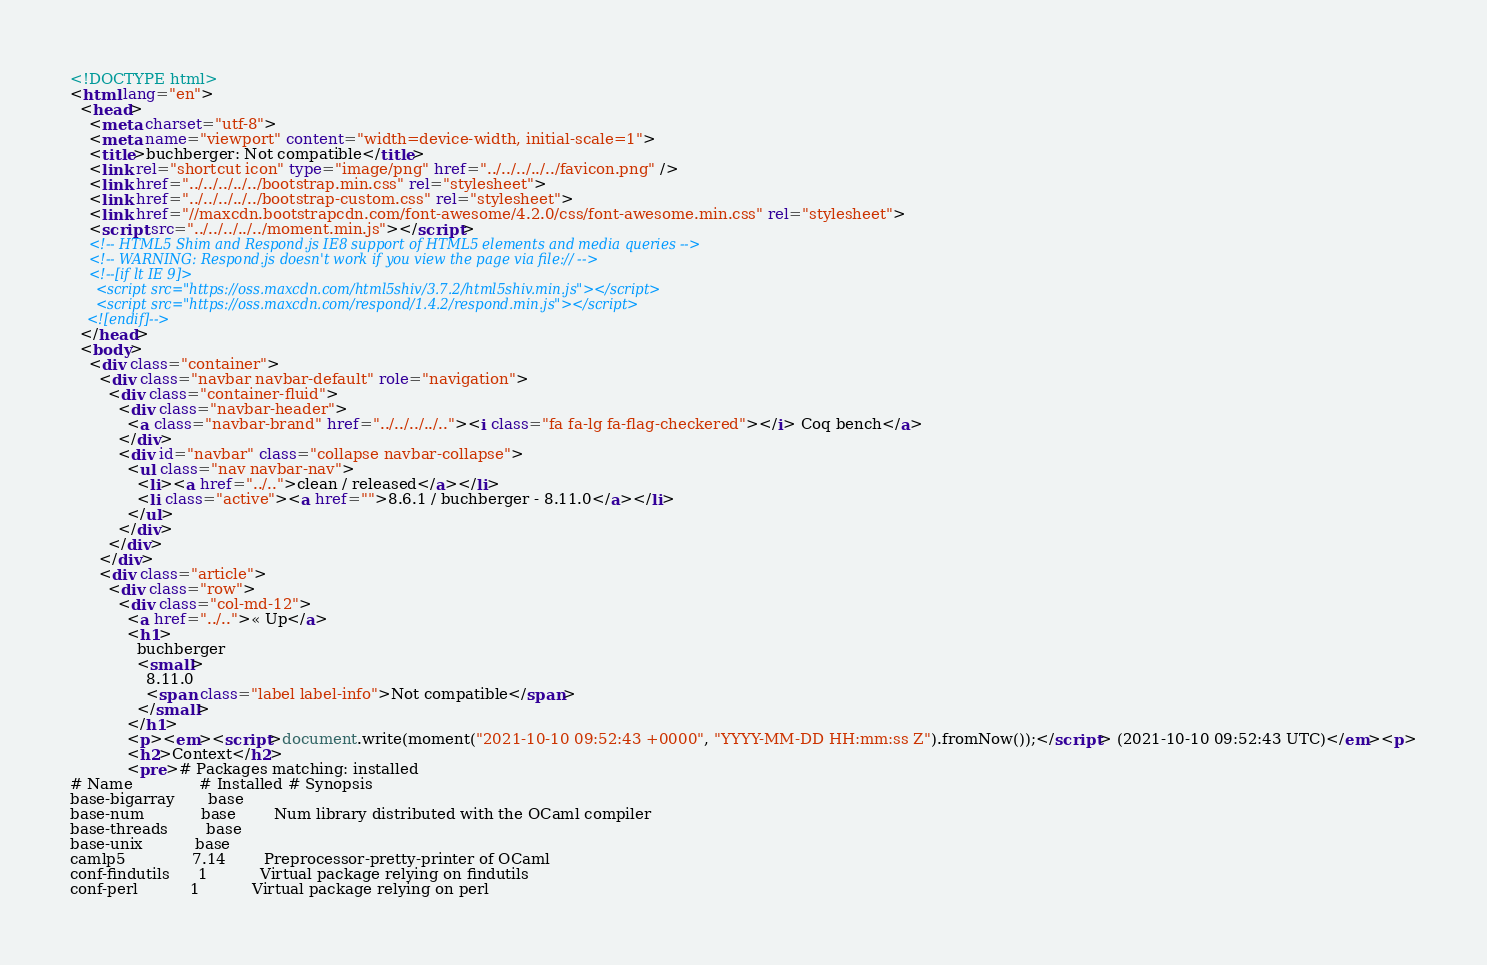<code> <loc_0><loc_0><loc_500><loc_500><_HTML_><!DOCTYPE html>
<html lang="en">
  <head>
    <meta charset="utf-8">
    <meta name="viewport" content="width=device-width, initial-scale=1">
    <title>buchberger: Not compatible</title>
    <link rel="shortcut icon" type="image/png" href="../../../../../favicon.png" />
    <link href="../../../../../bootstrap.min.css" rel="stylesheet">
    <link href="../../../../../bootstrap-custom.css" rel="stylesheet">
    <link href="//maxcdn.bootstrapcdn.com/font-awesome/4.2.0/css/font-awesome.min.css" rel="stylesheet">
    <script src="../../../../../moment.min.js"></script>
    <!-- HTML5 Shim and Respond.js IE8 support of HTML5 elements and media queries -->
    <!-- WARNING: Respond.js doesn't work if you view the page via file:// -->
    <!--[if lt IE 9]>
      <script src="https://oss.maxcdn.com/html5shiv/3.7.2/html5shiv.min.js"></script>
      <script src="https://oss.maxcdn.com/respond/1.4.2/respond.min.js"></script>
    <![endif]-->
  </head>
  <body>
    <div class="container">
      <div class="navbar navbar-default" role="navigation">
        <div class="container-fluid">
          <div class="navbar-header">
            <a class="navbar-brand" href="../../../../.."><i class="fa fa-lg fa-flag-checkered"></i> Coq bench</a>
          </div>
          <div id="navbar" class="collapse navbar-collapse">
            <ul class="nav navbar-nav">
              <li><a href="../..">clean / released</a></li>
              <li class="active"><a href="">8.6.1 / buchberger - 8.11.0</a></li>
            </ul>
          </div>
        </div>
      </div>
      <div class="article">
        <div class="row">
          <div class="col-md-12">
            <a href="../..">« Up</a>
            <h1>
              buchberger
              <small>
                8.11.0
                <span class="label label-info">Not compatible</span>
              </small>
            </h1>
            <p><em><script>document.write(moment("2021-10-10 09:52:43 +0000", "YYYY-MM-DD HH:mm:ss Z").fromNow());</script> (2021-10-10 09:52:43 UTC)</em><p>
            <h2>Context</h2>
            <pre># Packages matching: installed
# Name              # Installed # Synopsis
base-bigarray       base
base-num            base        Num library distributed with the OCaml compiler
base-threads        base
base-unix           base
camlp5              7.14        Preprocessor-pretty-printer of OCaml
conf-findutils      1           Virtual package relying on findutils
conf-perl           1           Virtual package relying on perl</code> 